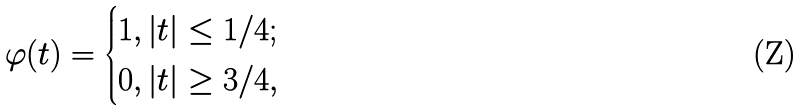Convert formula to latex. <formula><loc_0><loc_0><loc_500><loc_500>\varphi ( t ) = \begin{cases} 1 , | t | \leq 1 / 4 ; \\ 0 , | t | \geq 3 / 4 , \end{cases}</formula> 